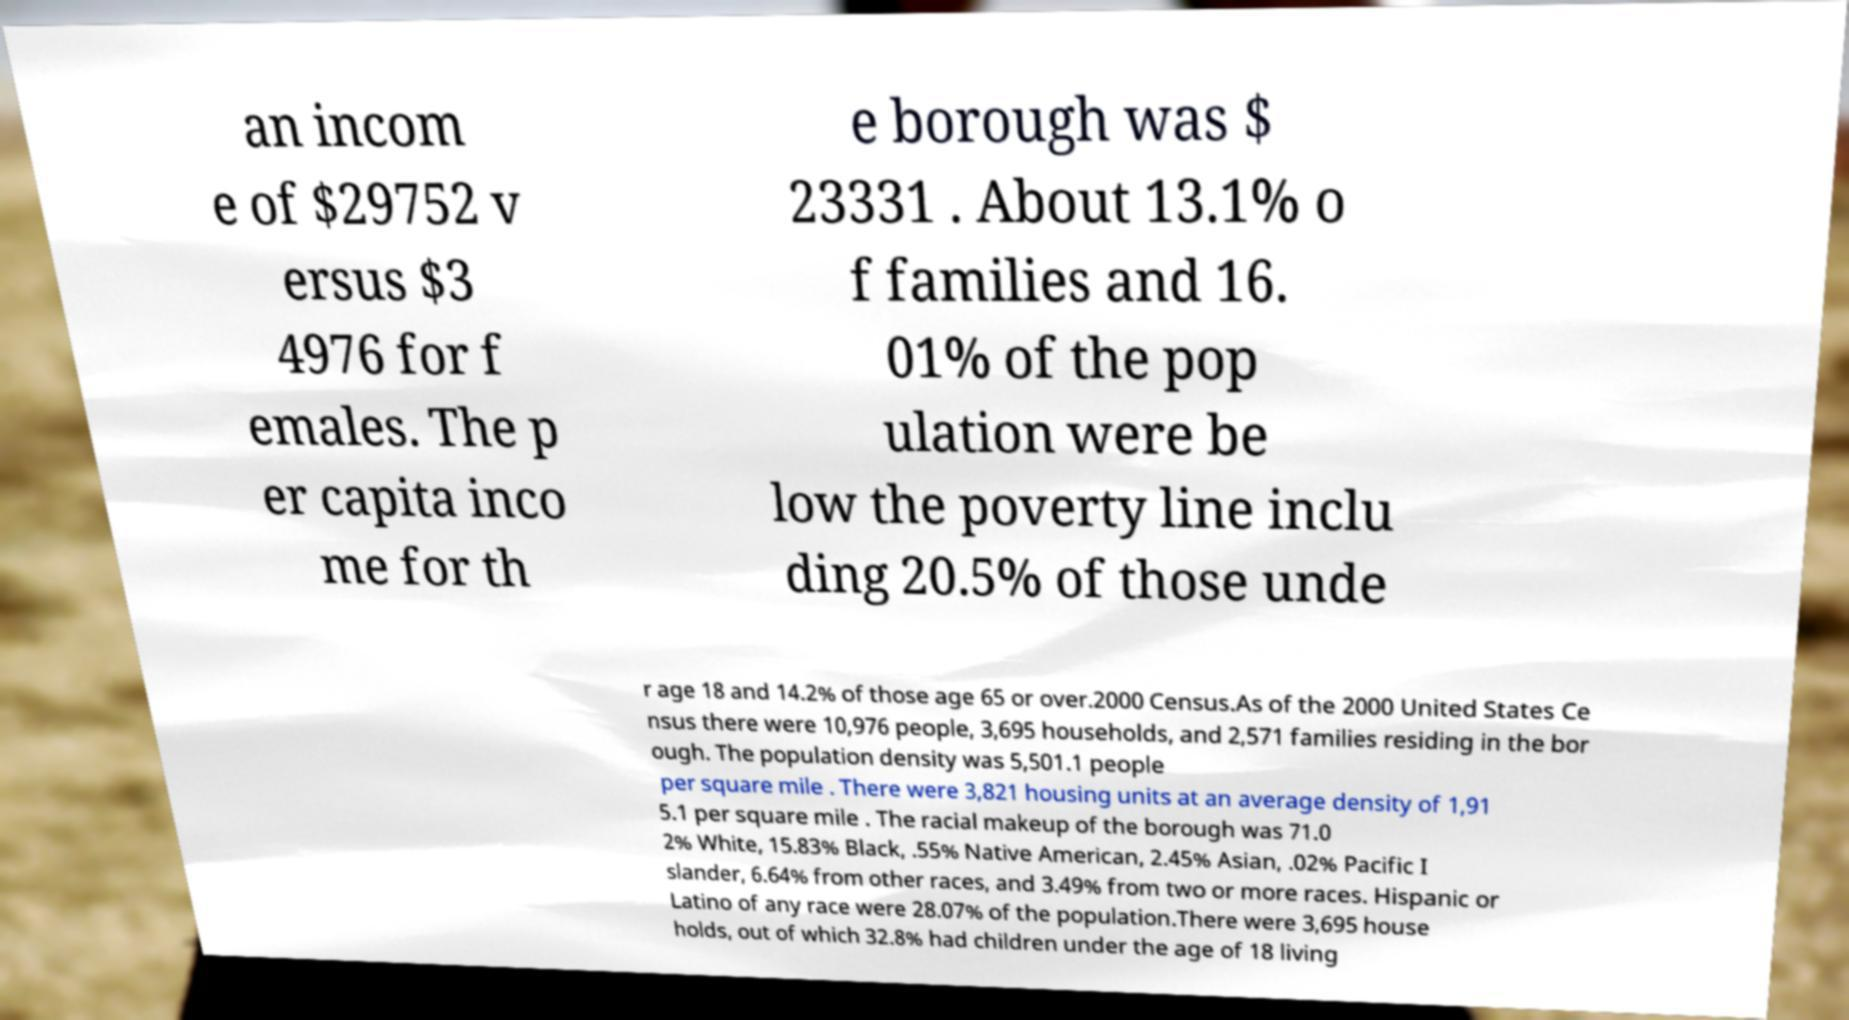Please read and relay the text visible in this image. What does it say? an incom e of $29752 v ersus $3 4976 for f emales. The p er capita inco me for th e borough was $ 23331 . About 13.1% o f families and 16. 01% of the pop ulation were be low the poverty line inclu ding 20.5% of those unde r age 18 and 14.2% of those age 65 or over.2000 Census.As of the 2000 United States Ce nsus there were 10,976 people, 3,695 households, and 2,571 families residing in the bor ough. The population density was 5,501.1 people per square mile . There were 3,821 housing units at an average density of 1,91 5.1 per square mile . The racial makeup of the borough was 71.0 2% White, 15.83% Black, .55% Native American, 2.45% Asian, .02% Pacific I slander, 6.64% from other races, and 3.49% from two or more races. Hispanic or Latino of any race were 28.07% of the population.There were 3,695 house holds, out of which 32.8% had children under the age of 18 living 